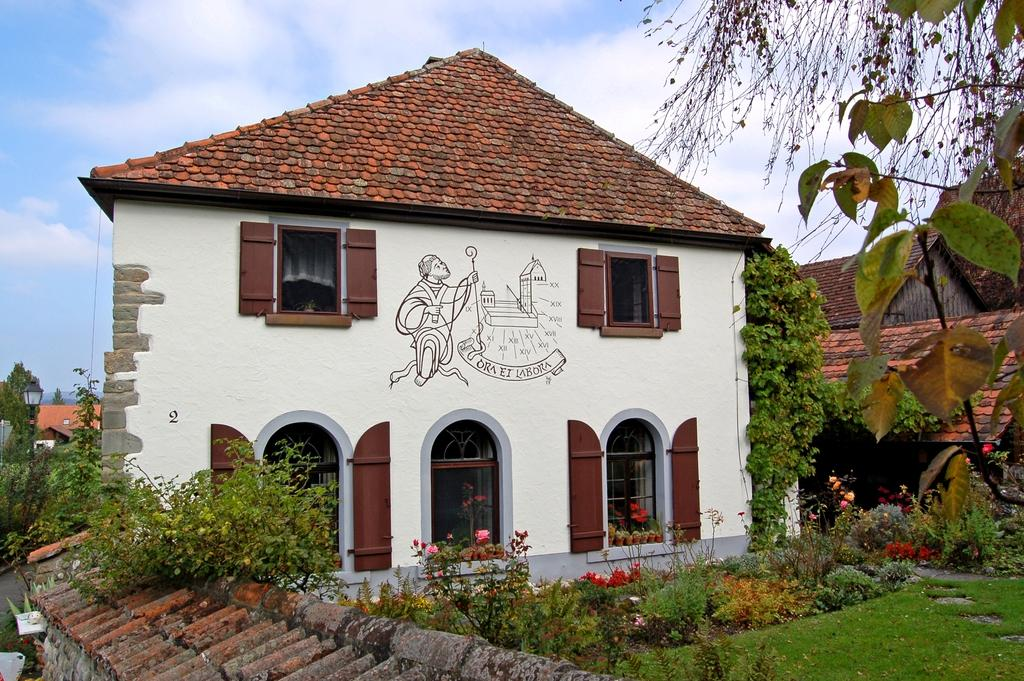What type of living organisms can be seen in the image? Plants can be seen in the image. What is located in the foreground of the image? There is a roof-like structure in the foreground of the image. What can be seen in the background of the image? Houses, trees, a lamp pole, and the sky are visible in the background of the image. What type of volleyball game is being played in the image? There is no volleyball game present in the image. Who is the manager of the plants in the image? The image does not have a manager, as it is a still image and not a living entity. 